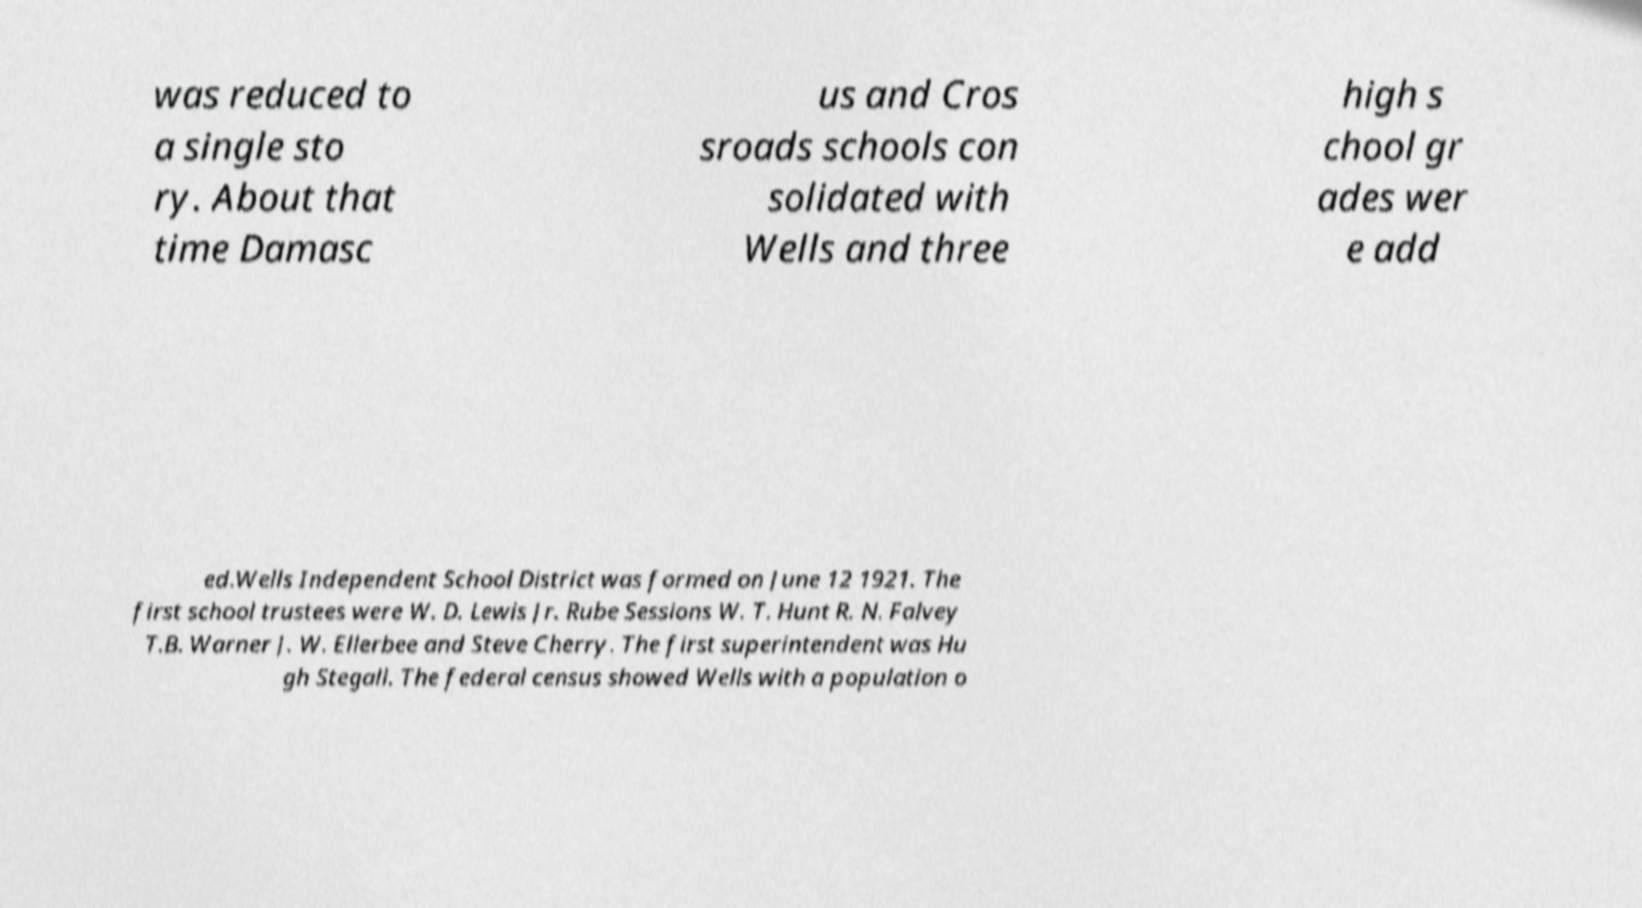What messages or text are displayed in this image? I need them in a readable, typed format. was reduced to a single sto ry. About that time Damasc us and Cros sroads schools con solidated with Wells and three high s chool gr ades wer e add ed.Wells Independent School District was formed on June 12 1921. The first school trustees were W. D. Lewis Jr. Rube Sessions W. T. Hunt R. N. Falvey T.B. Warner J. W. Ellerbee and Steve Cherry. The first superintendent was Hu gh Stegall. The federal census showed Wells with a population o 